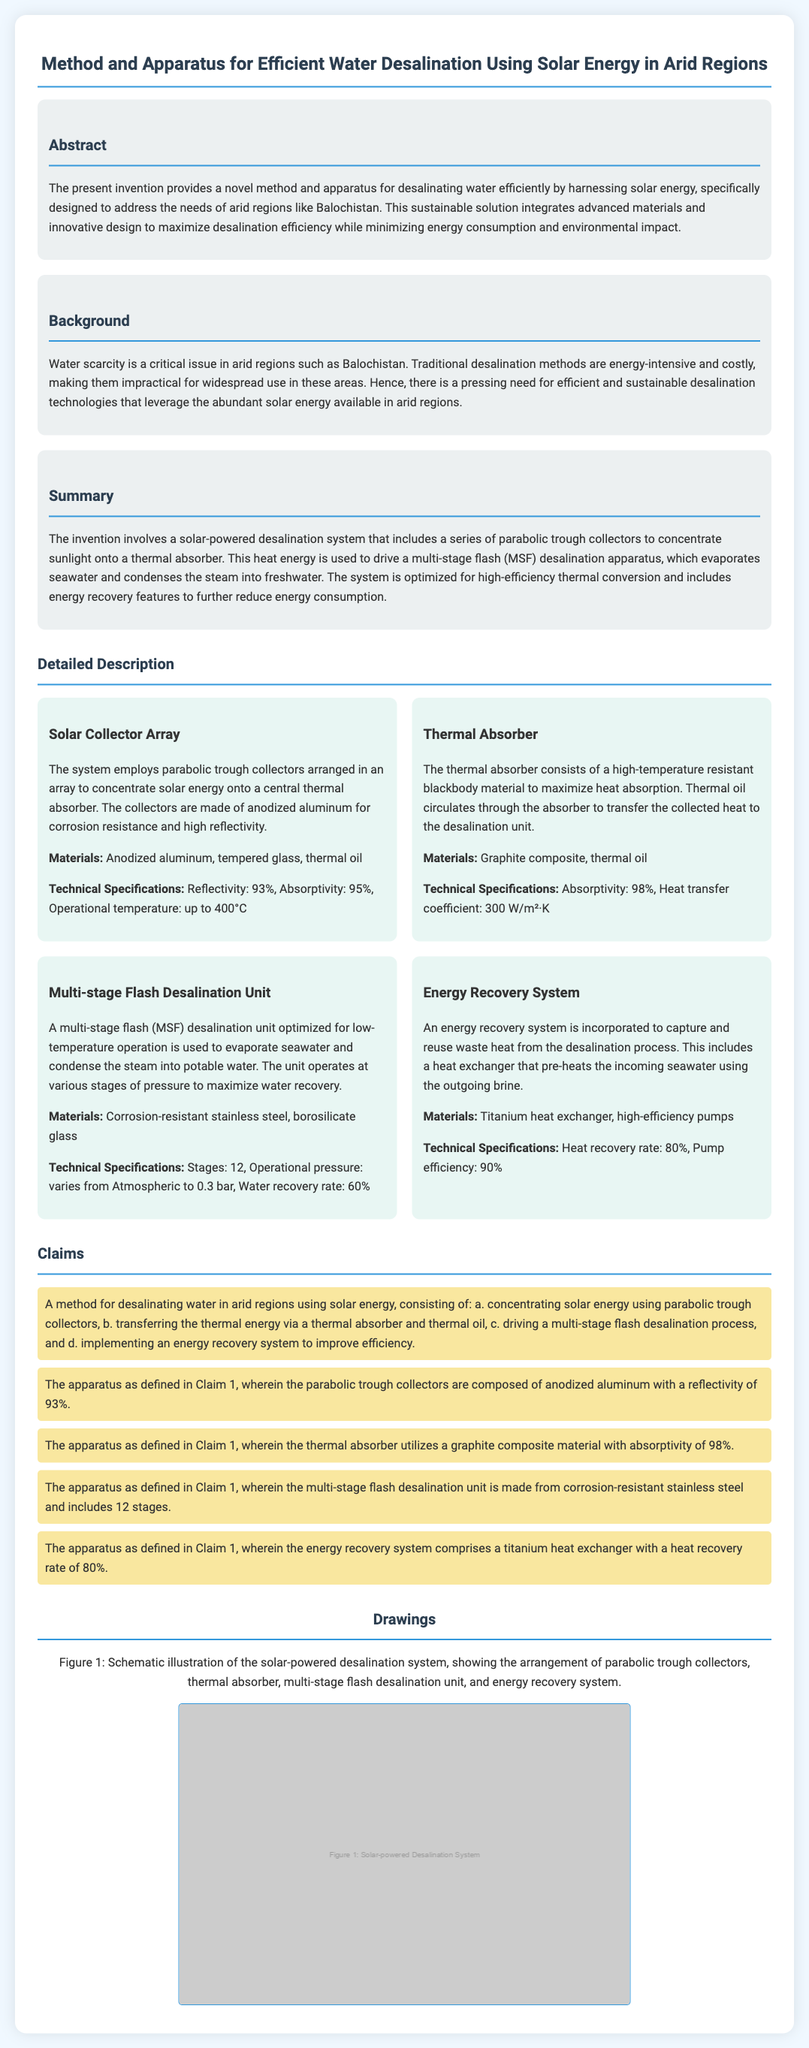What is the main purpose of the invention? The main purpose is to provide a novel method and apparatus for desalinating water efficiently by harnessing solar energy, specifically designed to address the needs of arid regions like Balochistan.
Answer: Desalinating water efficiently using solar energy What materials are used in the solar collector array? The materials listed for the solar collector array are anodized aluminum, tempered glass, and thermal oil.
Answer: Anodized aluminum, tempered glass, thermal oil What is the total number of stages in the multi-stage flash desalination unit? The document specifies that the multi-stage flash desalination unit has 12 stages.
Answer: 12 What is the heat recovery rate of the energy recovery system? The heat recovery rate specified in the document is 80%.
Answer: 80% What type of material is the thermal absorber made of? The thermal absorber is made of a graphite composite material that maximizes heat absorption.
Answer: Graphite composite What are the operational conditions of the multi-stage flash desalination unit? The operational conditions include varying pressure from Atmospheric to 0.3 bar.
Answer: Atmospheric to 0.3 bar How does the system maximize desalination efficiency? The system integrates advanced materials and innovative design to maximize desalination efficiency while minimizing energy consumption and environmental impact.
Answer: Advanced materials and innovative design Which component captures and reuses waste heat? The component that captures and reuses waste heat is the energy recovery system.
Answer: Energy recovery system 